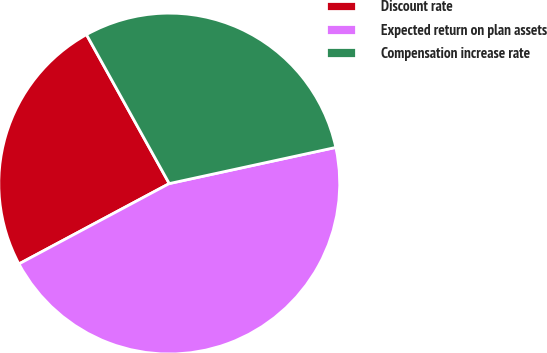<chart> <loc_0><loc_0><loc_500><loc_500><pie_chart><fcel>Discount rate<fcel>Expected return on plan assets<fcel>Compensation increase rate<nl><fcel>24.74%<fcel>45.59%<fcel>29.67%<nl></chart> 